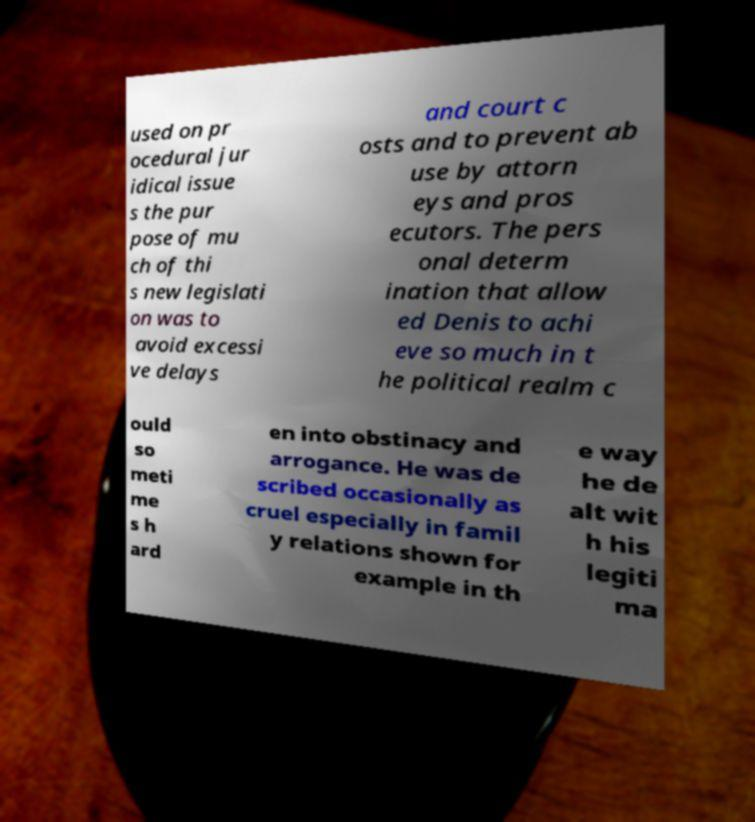I need the written content from this picture converted into text. Can you do that? used on pr ocedural jur idical issue s the pur pose of mu ch of thi s new legislati on was to avoid excessi ve delays and court c osts and to prevent ab use by attorn eys and pros ecutors. The pers onal determ ination that allow ed Denis to achi eve so much in t he political realm c ould so meti me s h ard en into obstinacy and arrogance. He was de scribed occasionally as cruel especially in famil y relations shown for example in th e way he de alt wit h his legiti ma 